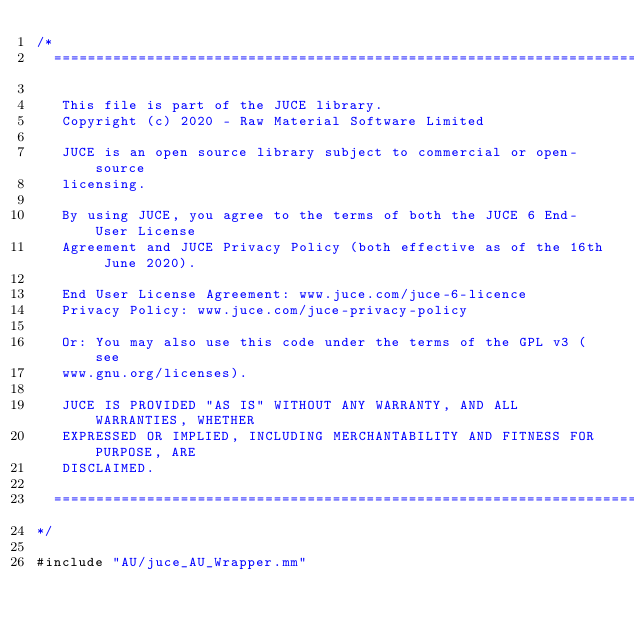<code> <loc_0><loc_0><loc_500><loc_500><_ObjectiveC_>/*
  ==============================================================================

   This file is part of the JUCE library.
   Copyright (c) 2020 - Raw Material Software Limited

   JUCE is an open source library subject to commercial or open-source
   licensing.

   By using JUCE, you agree to the terms of both the JUCE 6 End-User License
   Agreement and JUCE Privacy Policy (both effective as of the 16th June 2020).

   End User License Agreement: www.juce.com/juce-6-licence
   Privacy Policy: www.juce.com/juce-privacy-policy

   Or: You may also use this code under the terms of the GPL v3 (see
   www.gnu.org/licenses).

   JUCE IS PROVIDED "AS IS" WITHOUT ANY WARRANTY, AND ALL WARRANTIES, WHETHER
   EXPRESSED OR IMPLIED, INCLUDING MERCHANTABILITY AND FITNESS FOR PURPOSE, ARE
   DISCLAIMED.

  ==============================================================================
*/

#include "AU/juce_AU_Wrapper.mm"
</code> 